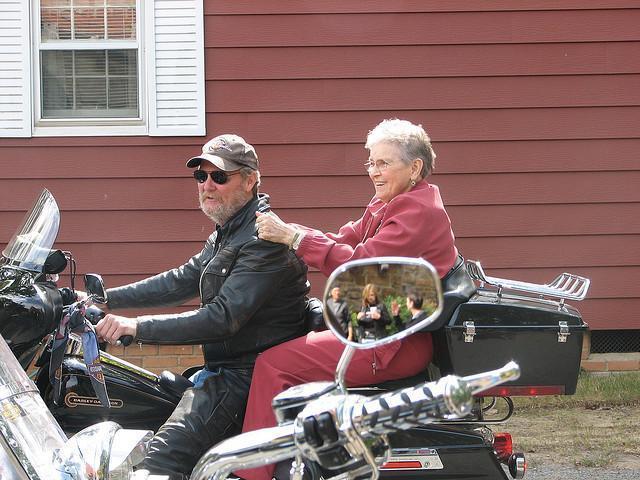How many people are there?
Give a very brief answer. 2. How many motorcycles are visible?
Give a very brief answer. 2. 